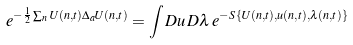<formula> <loc_0><loc_0><loc_500><loc_500>e ^ { - \frac { 1 } { 2 } \sum _ { n } U ( { n } , t ) \Delta _ { a } U ( { n } , t ) } = \int D u \, D \lambda \, e ^ { - S \{ U ( { n } , t ) , u ( { n } , t ) , \lambda ( { n } , t ) \} }</formula> 